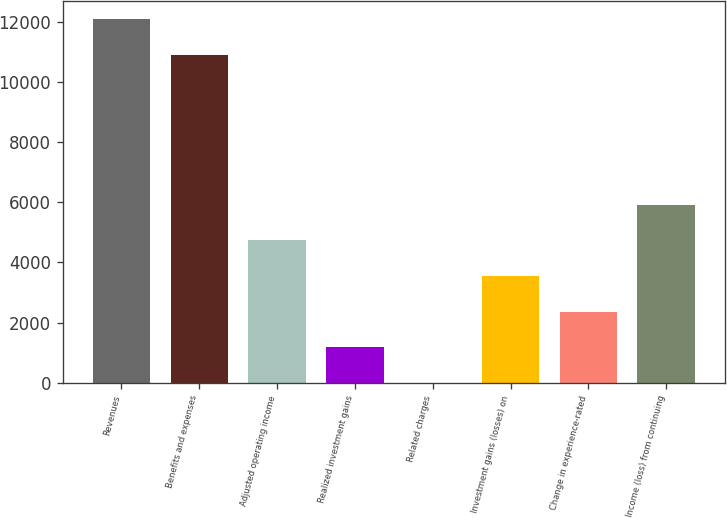Convert chart to OTSL. <chart><loc_0><loc_0><loc_500><loc_500><bar_chart><fcel>Revenues<fcel>Benefits and expenses<fcel>Adjusted operating income<fcel>Realized investment gains<fcel>Related charges<fcel>Investment gains (losses) on<fcel>Change in experience-rated<fcel>Income (loss) from continuing<nl><fcel>12072<fcel>10890<fcel>4729<fcel>1183<fcel>1<fcel>3547<fcel>2365<fcel>5911<nl></chart> 